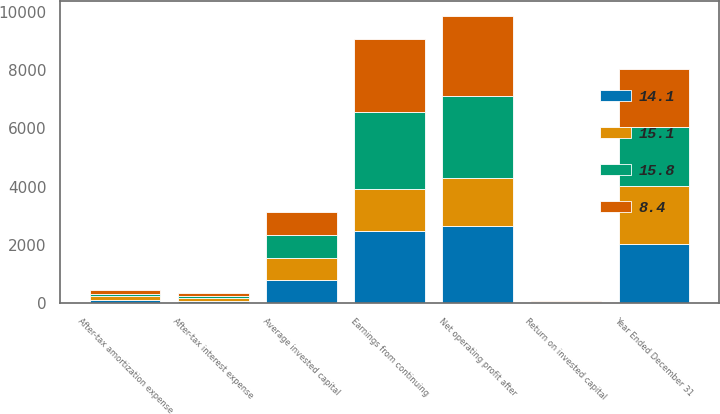<chart> <loc_0><loc_0><loc_500><loc_500><stacked_bar_chart><ecel><fcel>Year Ended December 31<fcel>Earnings from continuing<fcel>After-tax interest expense<fcel>After-tax amortization expense<fcel>Net operating profit after<fcel>Average invested capital<fcel>Return on invested capital<nl><fcel>15.8<fcel>2014<fcel>2673<fcel>67<fcel>79<fcel>2819<fcel>777.5<fcel>15.1<nl><fcel>14.1<fcel>2013<fcel>2486<fcel>67<fcel>93<fcel>2646<fcel>777.5<fcel>14.1<nl><fcel>15.1<fcel>2012<fcel>1414<fcel>109<fcel>139<fcel>1662<fcel>777.5<fcel>8.4<nl><fcel>8.4<fcel>2011<fcel>2500<fcel>101<fcel>141<fcel>2742<fcel>777.5<fcel>14.7<nl></chart> 